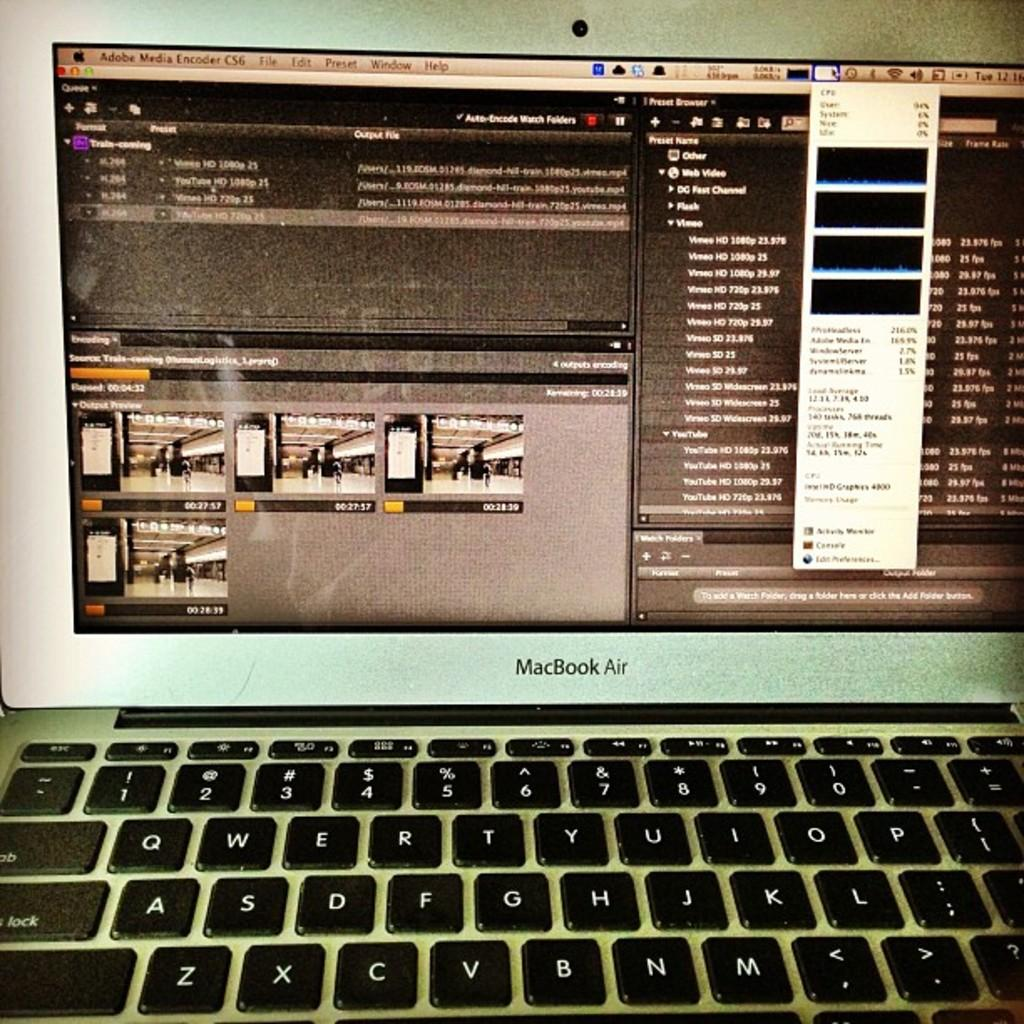<image>
Provide a brief description of the given image. A MacBook Air computer is open with an Adobe program running. 